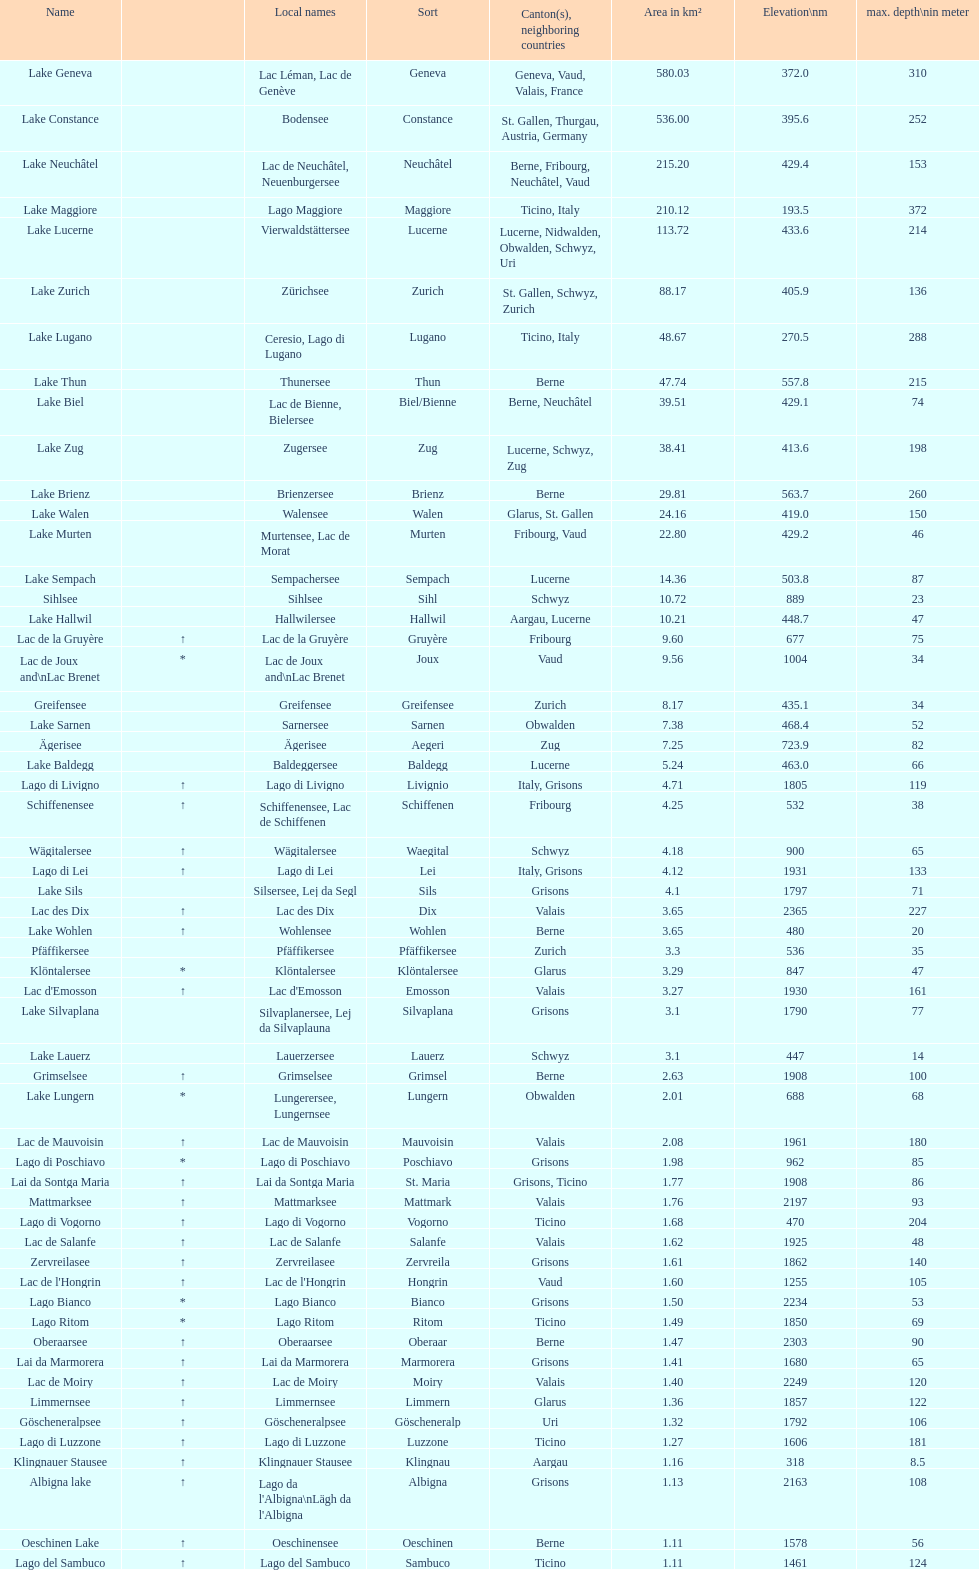Which lake is located at an elevation above 193m? Lake Maggiore. 